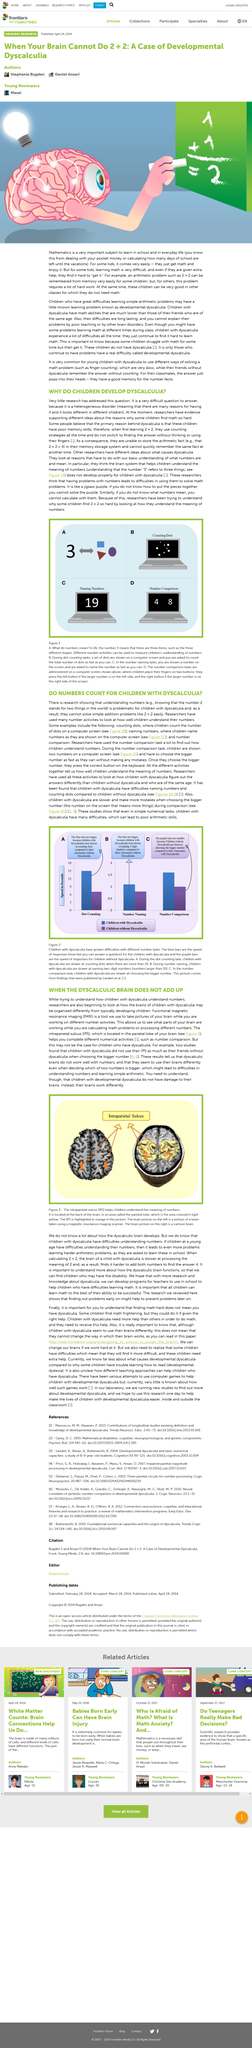Give some essential details in this illustration. The intraparietal sulcus is located in the parietal lobe of the brain. The intraparietal sulcus is highlighted in orange in the picture. The parietal lobe, which is colored in light yellow in the image, is the part of the brain that is being referred to. The blue bars represent the speed of answers for children with dyscalculia. The number written on the computer in picture C is 19. 